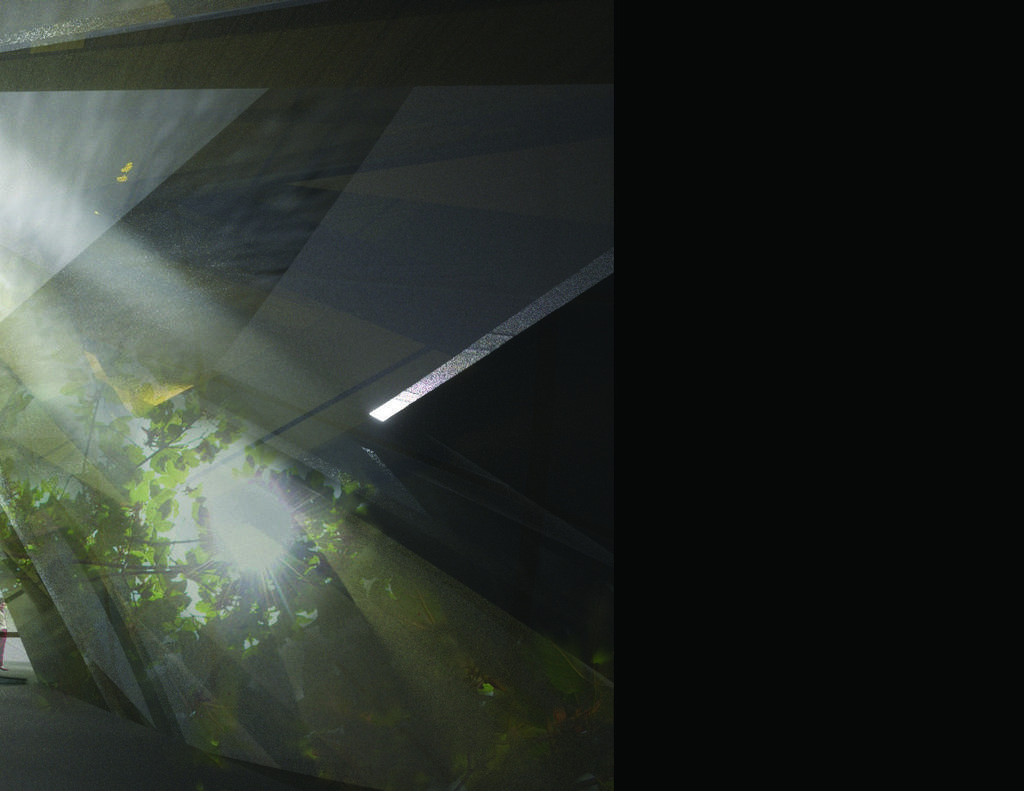Describe this image in one or two sentences. In this image, I can see the trees, light and an object. There is a dark background. 